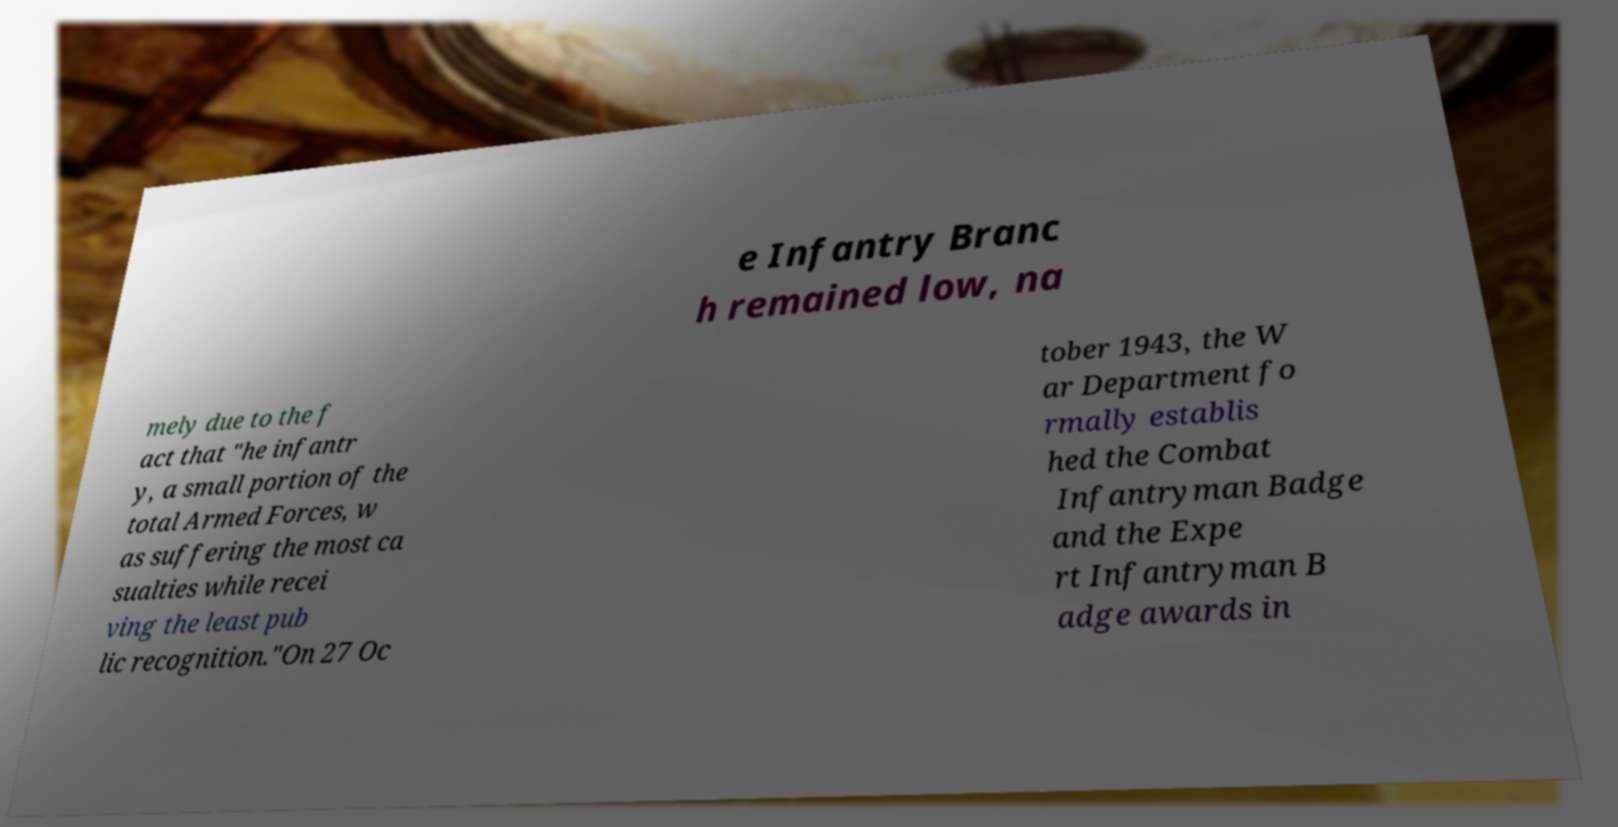Can you accurately transcribe the text from the provided image for me? e Infantry Branc h remained low, na mely due to the f act that "he infantr y, a small portion of the total Armed Forces, w as suffering the most ca sualties while recei ving the least pub lic recognition."On 27 Oc tober 1943, the W ar Department fo rmally establis hed the Combat Infantryman Badge and the Expe rt Infantryman B adge awards in 